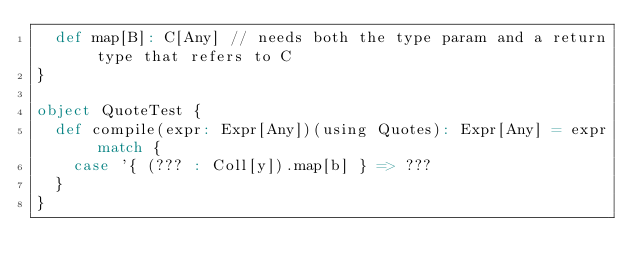<code> <loc_0><loc_0><loc_500><loc_500><_Scala_>  def map[B]: C[Any] // needs both the type param and a return type that refers to C
}

object QuoteTest {
  def compile(expr: Expr[Any])(using Quotes): Expr[Any] = expr match {
    case '{ (??? : Coll[y]).map[b] } => ???
  }
}
</code> 